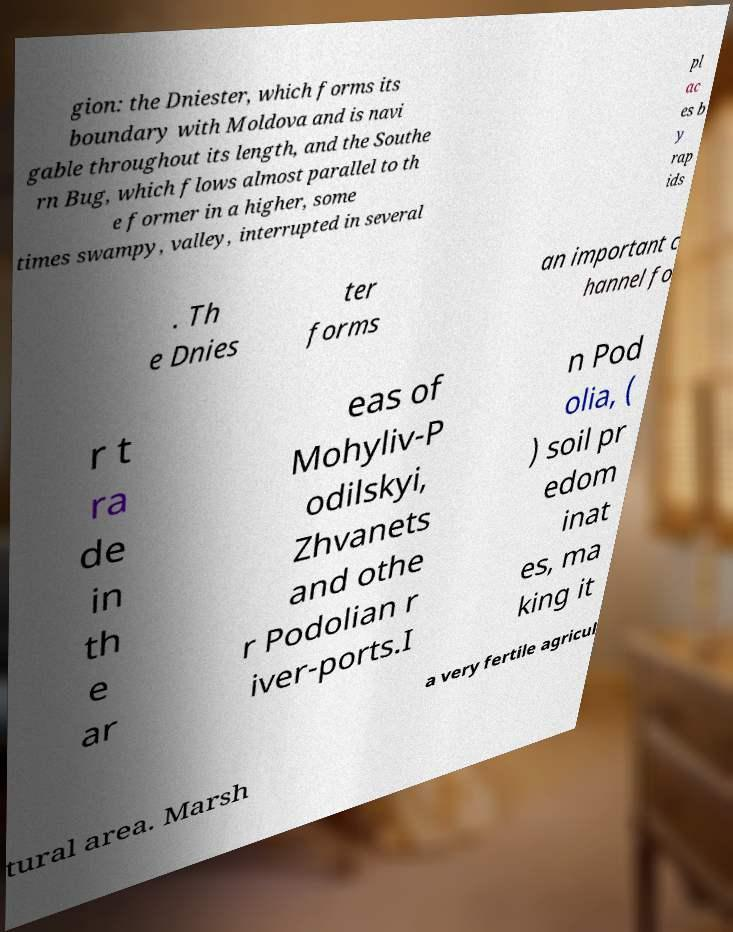For documentation purposes, I need the text within this image transcribed. Could you provide that? gion: the Dniester, which forms its boundary with Moldova and is navi gable throughout its length, and the Southe rn Bug, which flows almost parallel to th e former in a higher, some times swampy, valley, interrupted in several pl ac es b y rap ids . Th e Dnies ter forms an important c hannel fo r t ra de in th e ar eas of Mohyliv-P odilskyi, Zhvanets and othe r Podolian r iver-ports.I n Pod olia, ( ) soil pr edom inat es, ma king it a very fertile agricul tural area. Marsh 